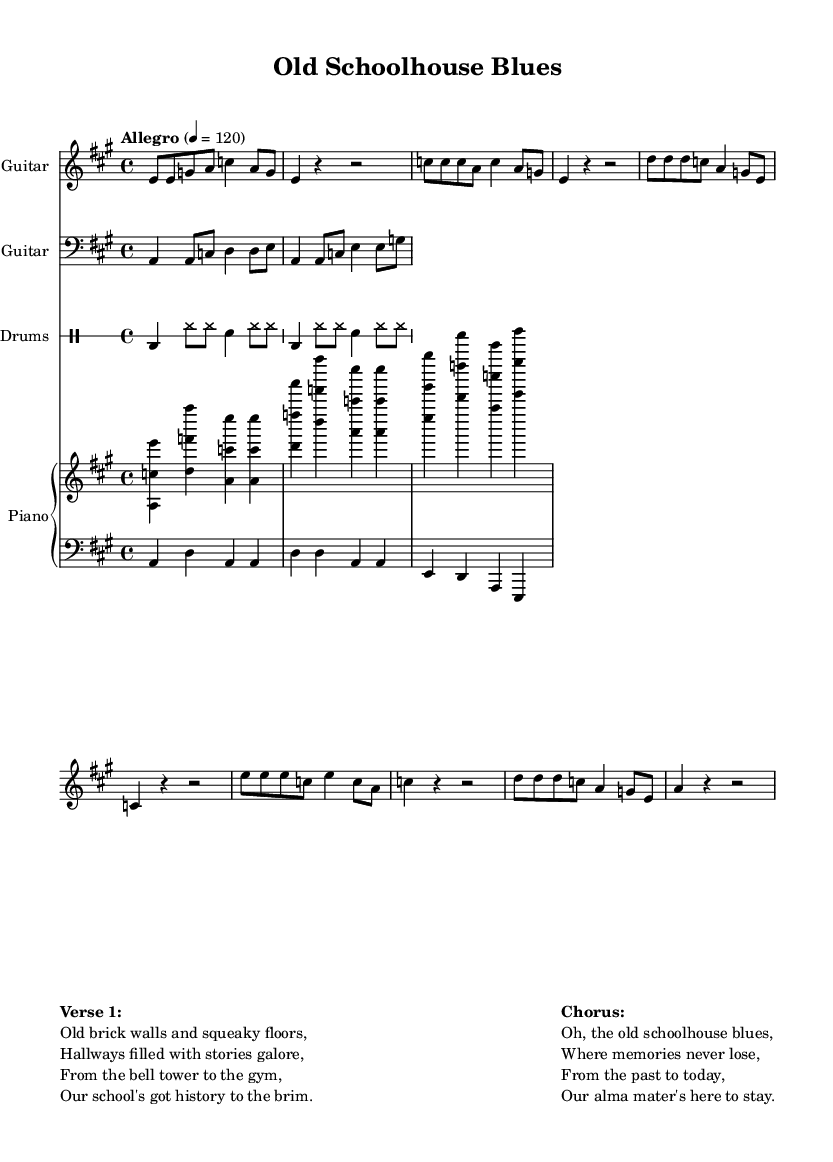What is the key signature of this music? The key signature is A major, which has three sharps (F#, C#, and G#). We can identify the key signature by checking the symbol at the beginning of the staff, which indicates the specific sharps or flats used in this piece.
Answer: A major What is the time signature of this music? The time signature is 4/4, which means there are four beats in each measure and the quarter note receives one beat. This can be found at the beginning of the sheet music, displayed as a fraction.
Answer: 4/4 What is the tempo of this music? The tempo marking is "Allegro" at a speed of 120 beats per minute. This information is usually found at the start of the score, indicating how fast the piece should be played.
Answer: Allegro 4 = 120 How many measures are in the main chorus section? The main chorus section consists of four measures. By counting the measures indicated in the chorus section of the music, each has a vertical line separating them.
Answer: 4 What instrument plays the bass line? The bass line is played by the bass guitar, which is commonly written in the bass clef. This can be determined by looking for the clef symbol at the beginning of the bass staff.
Answer: Bass Guitar What is the chord progression in the right hand of the piano part? The chord progression in the right hand consists of A major, D major, A major, and E major. By analyzing the notes played together in the right hand, we can identify the chords formed.
Answer: A major, D major, A major, E major What is the song's title? The song's title is "Old Schoolhouse Blues". This is typically found at the top of the sheet music, labeled clearly under the header section.
Answer: Old Schoolhouse Blues 